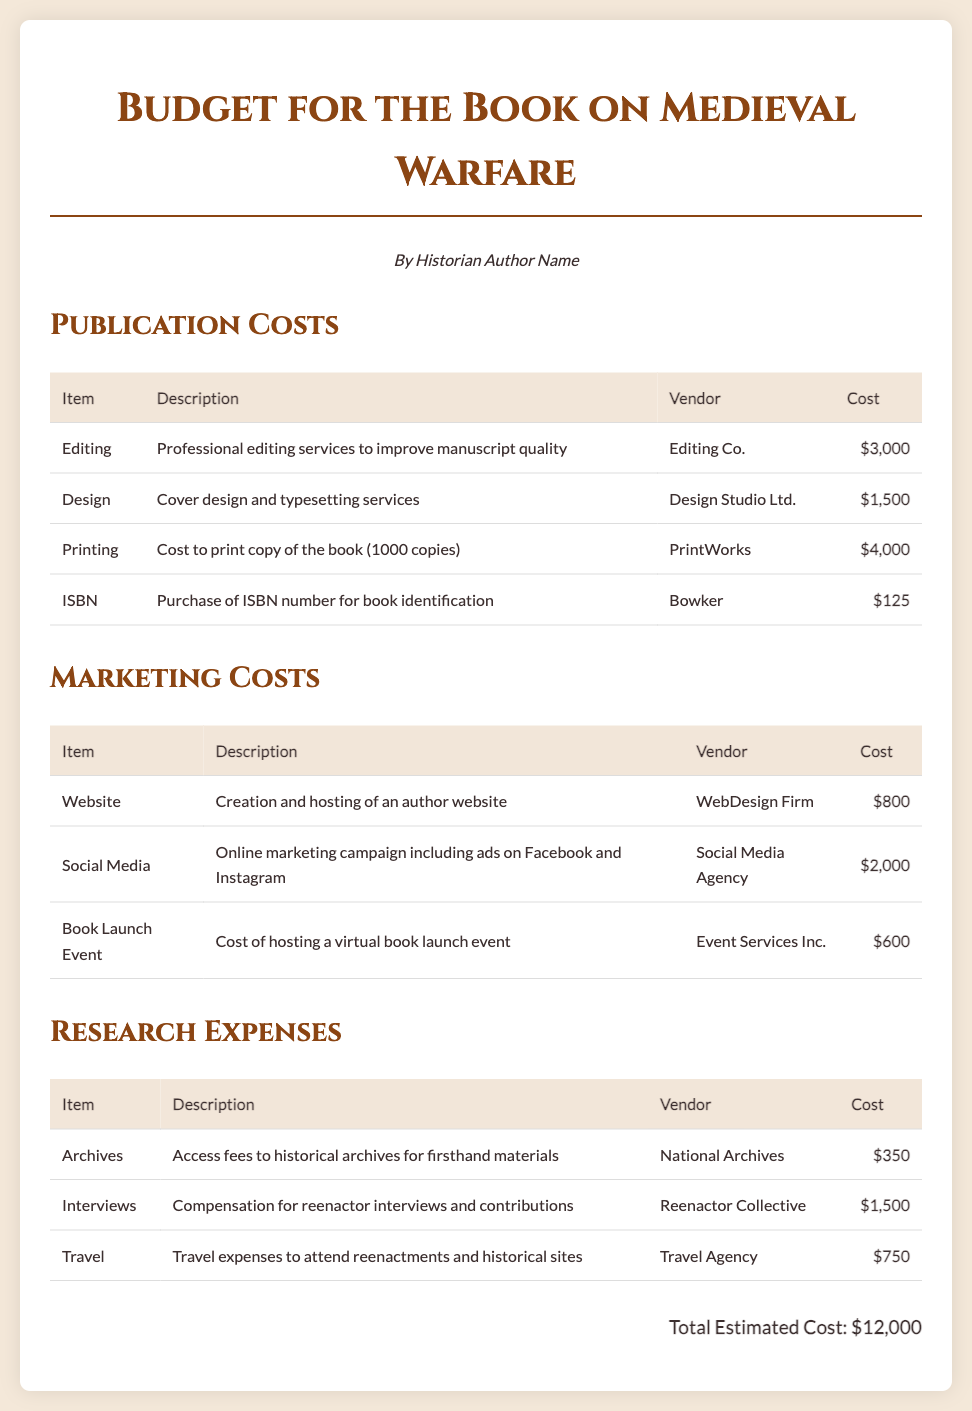what is the total estimated cost? The total estimated cost is presented at the end of the document, summing up all individual costs listed, which is $12,000.
Answer: $12,000 who provides editing services? The document lists "Editing Co." as the vendor for professional editing services.
Answer: Editing Co how much is allocated for the book launch event? The cost for the book launch event is detailed in the marketing section of the document, which is $600.
Answer: $600 what is the cost of travel expenses? Travel expenses are mentioned under research expenses, with a specified cost of $750.
Answer: $750 how much is budgeted for social media marketing? The cost for the online marketing campaign including ads on social media is $2,000, as shown in the marketing section.
Answer: $2,000 what type of document is this? The document outlines estimated costs related to the publication of a book, making it a project budget document.
Answer: Project budget document who is responsible for the cover design? The vendor listed for cover design and typesetting services is "Design Studio Ltd."
Answer: Design Studio Ltd what are the research expenses for interviews? Compensation for reenactor interviews and contributions amounts to $1,500, as specified in the research expenses section.
Answer: $1,500 what is the description of the printing cost? The printing cost is described as the cost to print copies of the book, specifically for 1000 copies.
Answer: Cost to print copy of the book (1000 copies) 